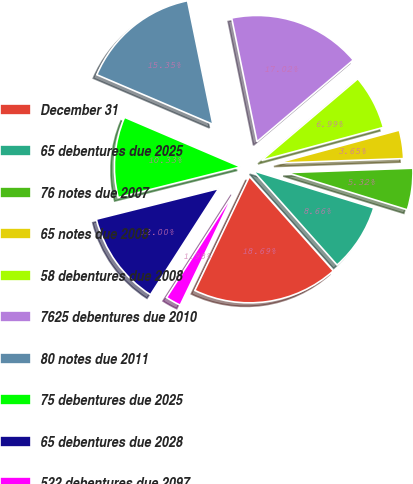<chart> <loc_0><loc_0><loc_500><loc_500><pie_chart><fcel>December 31<fcel>65 debentures due 2025<fcel>76 notes due 2007<fcel>65 notes due 2008<fcel>58 debentures due 2008<fcel>7625 debentures due 2010<fcel>80 notes due 2011<fcel>75 debentures due 2025<fcel>65 debentures due 2028<fcel>522 debentures due 2097<nl><fcel>18.69%<fcel>8.66%<fcel>5.32%<fcel>3.65%<fcel>6.99%<fcel>17.02%<fcel>15.35%<fcel>10.33%<fcel>12.0%<fcel>1.98%<nl></chart> 